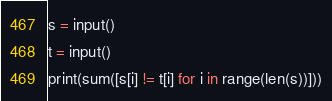<code> <loc_0><loc_0><loc_500><loc_500><_Python_>s = input()
t = input()
print(sum([s[i] != t[i] for i in range(len(s))]))</code> 